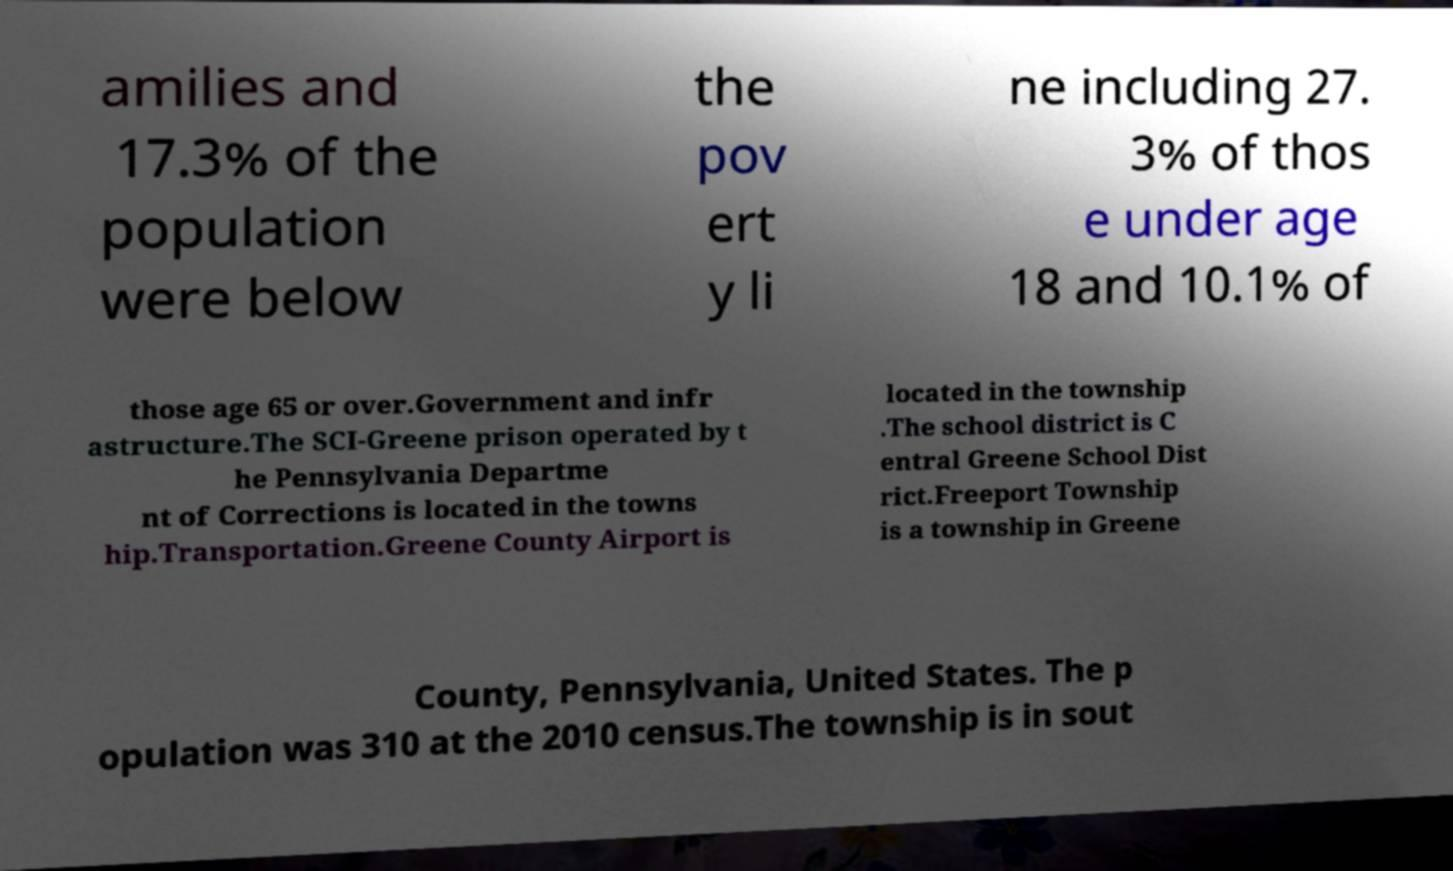Please identify and transcribe the text found in this image. amilies and 17.3% of the population were below the pov ert y li ne including 27. 3% of thos e under age 18 and 10.1% of those age 65 or over.Government and infr astructure.The SCI-Greene prison operated by t he Pennsylvania Departme nt of Corrections is located in the towns hip.Transportation.Greene County Airport is located in the township .The school district is C entral Greene School Dist rict.Freeport Township is a township in Greene County, Pennsylvania, United States. The p opulation was 310 at the 2010 census.The township is in sout 